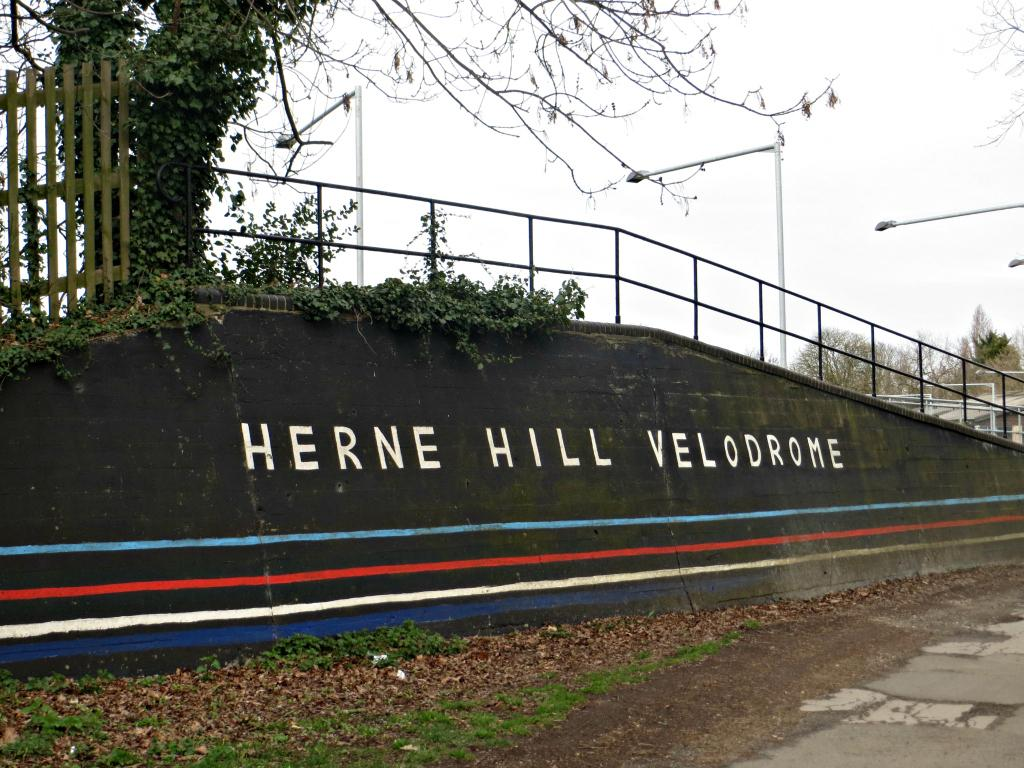<image>
Relay a brief, clear account of the picture shown. A black wall has white letters that say Herne Hill Velodrome. 